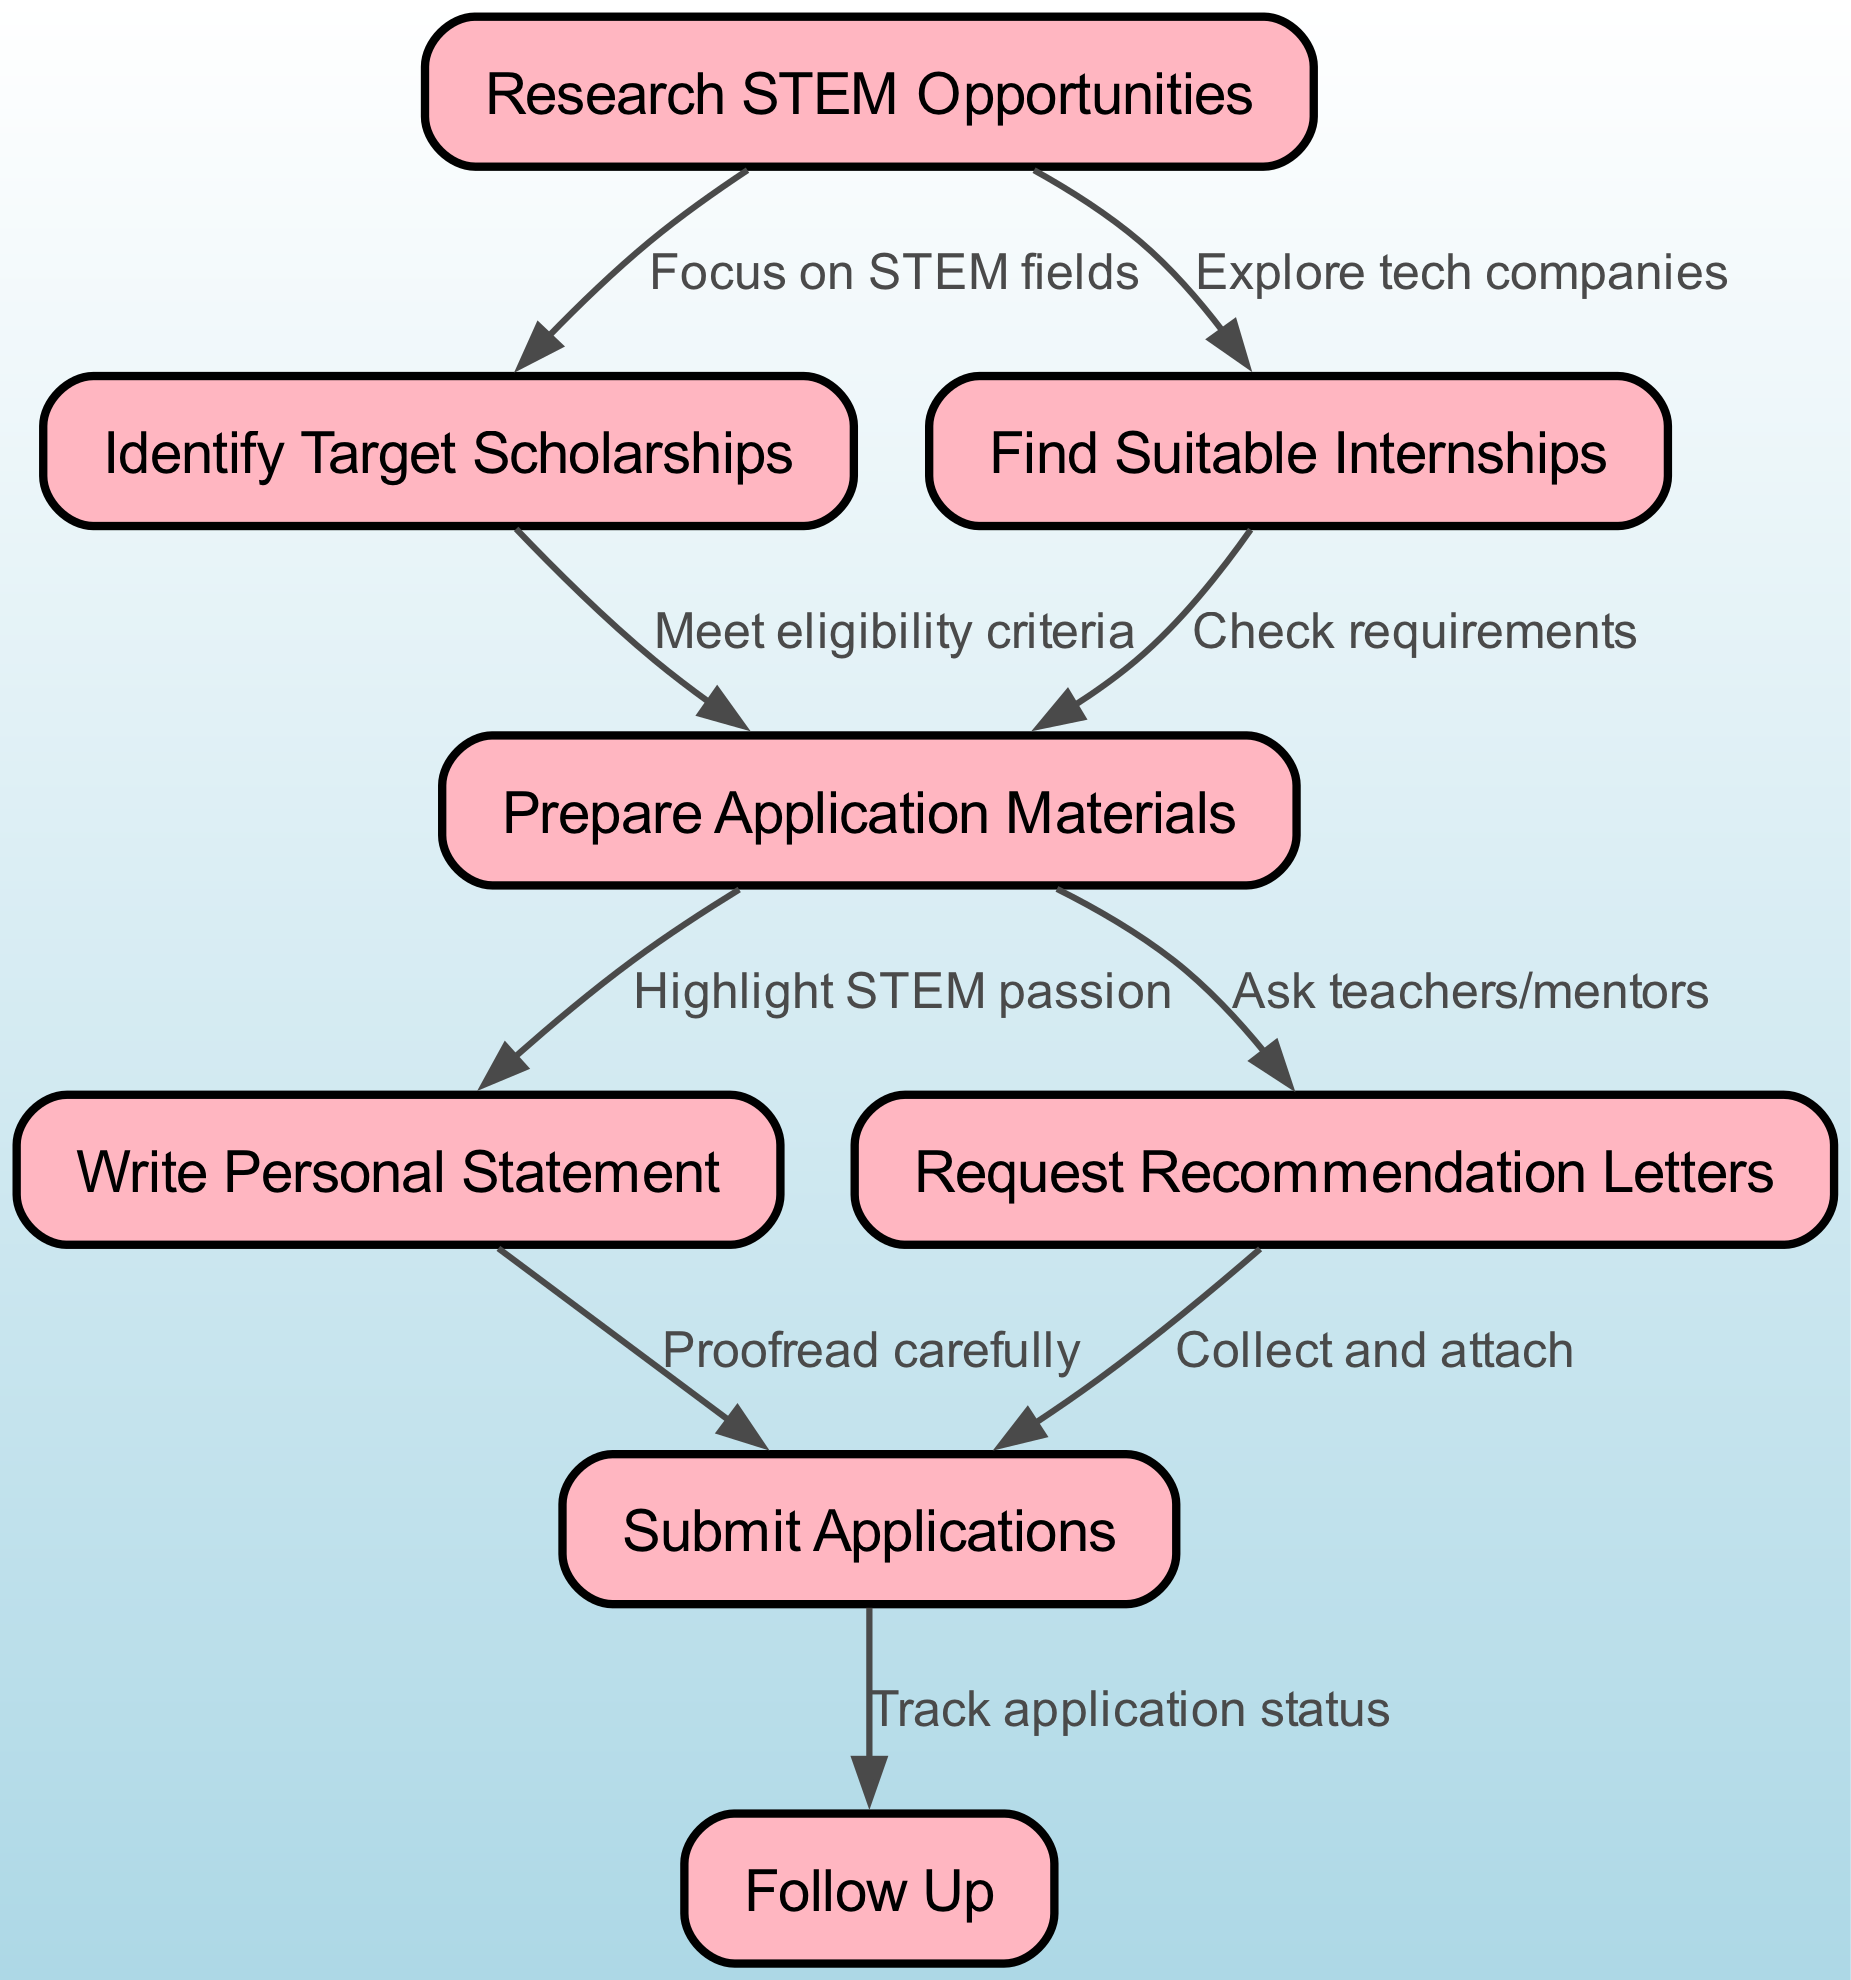What is the total number of nodes in the diagram? By counting each labeled node in the flowchart, there are eight distinct nodes listed: Research STEM Opportunities, Identify Target Scholarships, Find Suitable Internships, Prepare Application Materials, Write Personal Statement, Request Recommendation Letters, Submit Applications, and Follow Up.
Answer: 8 What is the first step in applying for STEM opportunities? The flowchart starts with the node labeled "Research STEM Opportunities," which indicates the initial action one should take.
Answer: Research STEM Opportunities Which two nodes are connected directly by an edge labeled "Check requirements"? The edge labeled "Check requirements" connects the nodes "Find Suitable Internships" and "Prepare Application Materials."
Answer: Find Suitable Internships and Prepare Application Materials What is the relationship between "Prepare Application Materials" and "Write Personal Statement"? The relationship is indicated by a directed edge showing that after preparing application materials, the next step is to "Write Personal Statement," linking the two processes in order.
Answer: Write Personal Statement How many edges are there that connect to "Submit Applications"? There are two edges that connect to "Submit Applications": one from "Write Personal Statement" and another from "Request Recommendation Letters," indicating multiple prerequisites lead to the submission stage.
Answer: 2 What step follows "Submit Applications"? According to the diagram, the step that directly follows "Submit Applications" is "Follow Up," indicating that one should check back after the submissions are made.
Answer: Follow Up Which nodes must be completed before submitting applications? Before reaching "Submit Applications," you must first complete both "Write Personal Statement" and "Request Recommendation Letters," as both are required and connect to this step.
Answer: Write Personal Statement and Request Recommendation Letters What is the connection between the node "Research STEM Opportunities" and "Identify Target Scholarships"? The node "Research STEM Opportunities" connects to "Identify Target Scholarships" through a directed edge labeled "Focus on STEM fields," showing the influence of the initial research on identifying scholarships.
Answer: Focus on STEM fields 